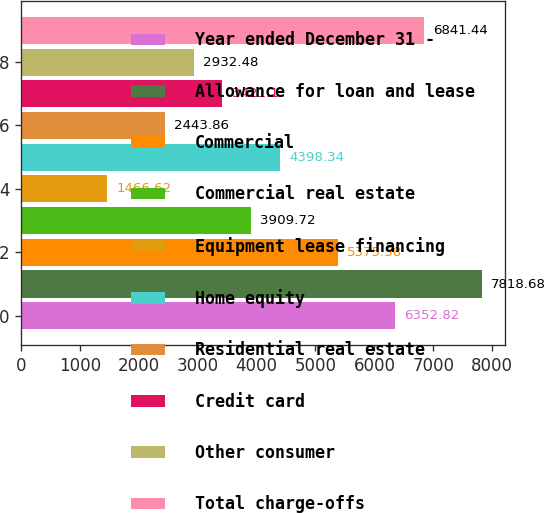Convert chart to OTSL. <chart><loc_0><loc_0><loc_500><loc_500><bar_chart><fcel>Year ended December 31 -<fcel>Allowance for loan and lease<fcel>Commercial<fcel>Commercial real estate<fcel>Equipment lease financing<fcel>Home equity<fcel>Residential real estate<fcel>Credit card<fcel>Other consumer<fcel>Total charge-offs<nl><fcel>6352.82<fcel>7818.68<fcel>5375.58<fcel>3909.72<fcel>1466.62<fcel>4398.34<fcel>2443.86<fcel>3421.1<fcel>2932.48<fcel>6841.44<nl></chart> 